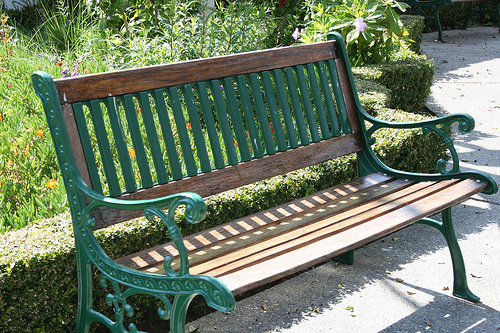Can you describe the surrounding area of the bench? The bench is located in a tranquil garden setting, flanked by neatly trimmed hedges. The greenery surrounding the bench suggests a well-maintained park or private garden. The presence of flowers and plants in the background provides a serene and picturesque environment in which to relax. 